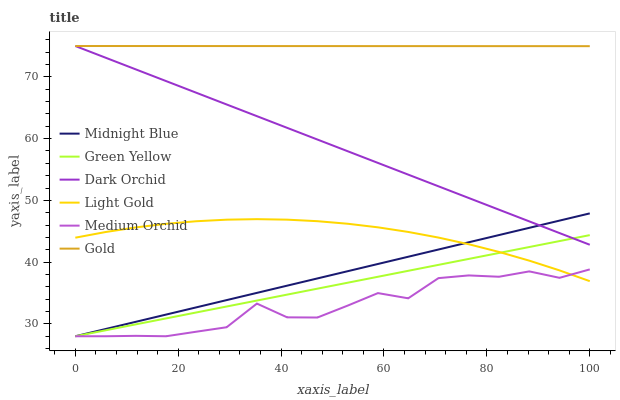Does Medium Orchid have the minimum area under the curve?
Answer yes or no. Yes. Does Gold have the maximum area under the curve?
Answer yes or no. Yes. Does Gold have the minimum area under the curve?
Answer yes or no. No. Does Medium Orchid have the maximum area under the curve?
Answer yes or no. No. Is Green Yellow the smoothest?
Answer yes or no. Yes. Is Medium Orchid the roughest?
Answer yes or no. Yes. Is Gold the smoothest?
Answer yes or no. No. Is Gold the roughest?
Answer yes or no. No. Does Midnight Blue have the lowest value?
Answer yes or no. Yes. Does Gold have the lowest value?
Answer yes or no. No. Does Dark Orchid have the highest value?
Answer yes or no. Yes. Does Medium Orchid have the highest value?
Answer yes or no. No. Is Midnight Blue less than Gold?
Answer yes or no. Yes. Is Gold greater than Midnight Blue?
Answer yes or no. Yes. Does Gold intersect Dark Orchid?
Answer yes or no. Yes. Is Gold less than Dark Orchid?
Answer yes or no. No. Is Gold greater than Dark Orchid?
Answer yes or no. No. Does Midnight Blue intersect Gold?
Answer yes or no. No. 